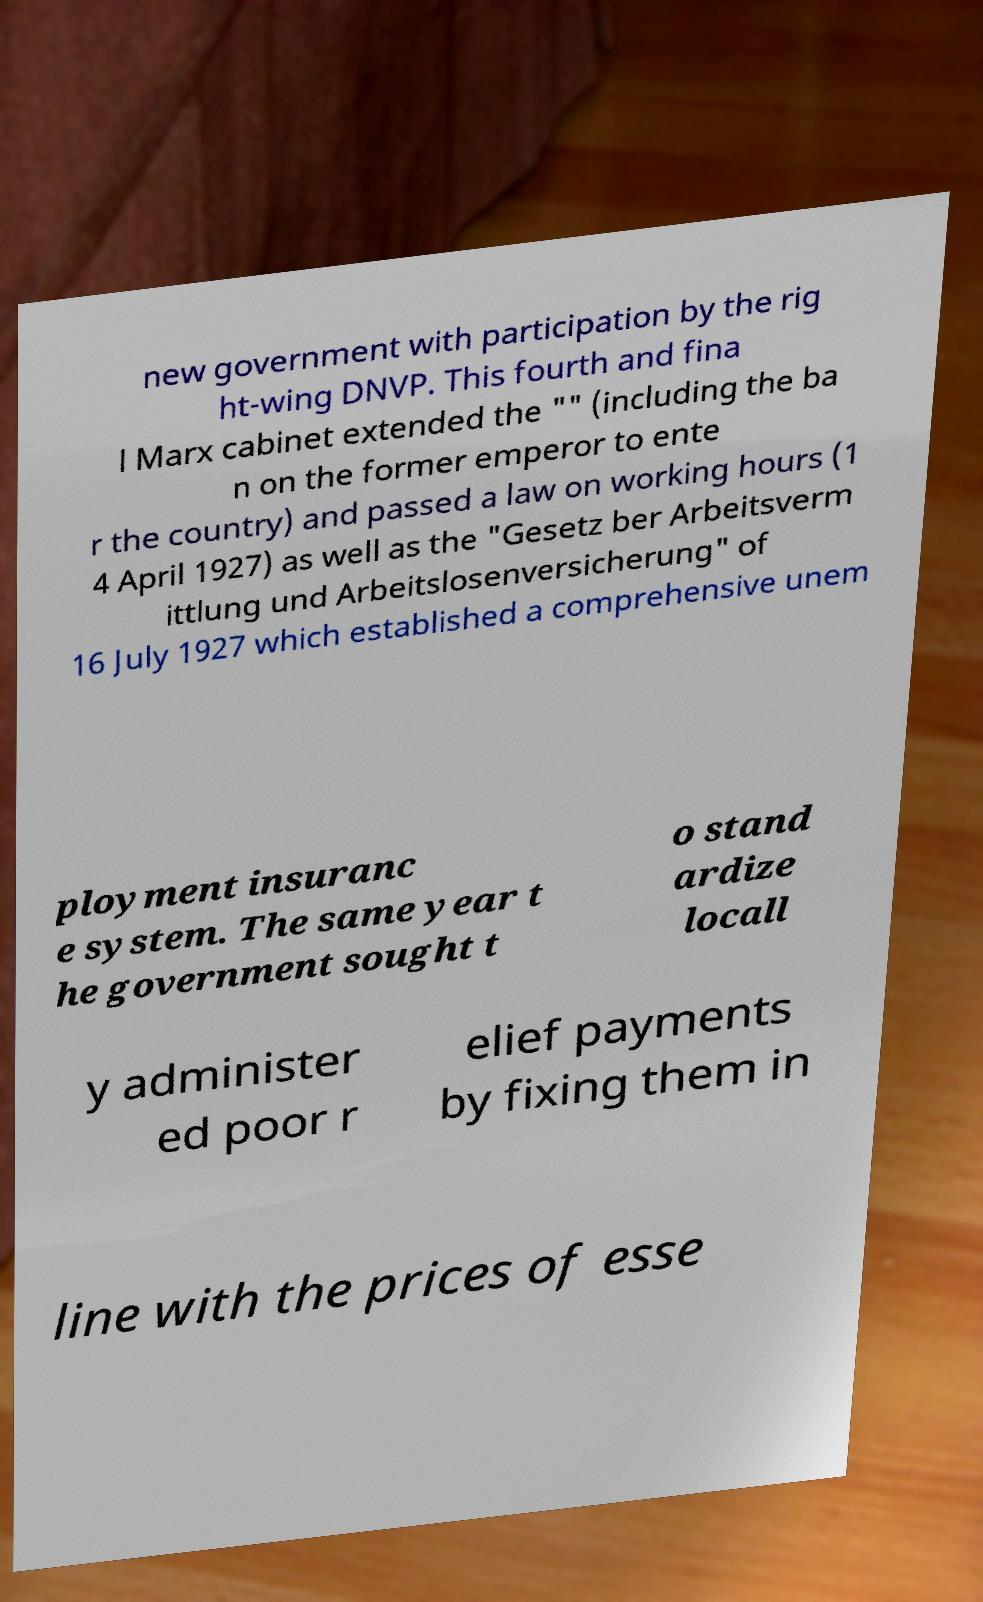Please read and relay the text visible in this image. What does it say? new government with participation by the rig ht-wing DNVP. This fourth and fina l Marx cabinet extended the "" (including the ba n on the former emperor to ente r the country) and passed a law on working hours (1 4 April 1927) as well as the "Gesetz ber Arbeitsverm ittlung und Arbeitslosenversicherung" of 16 July 1927 which established a comprehensive unem ployment insuranc e system. The same year t he government sought t o stand ardize locall y administer ed poor r elief payments by fixing them in line with the prices of esse 